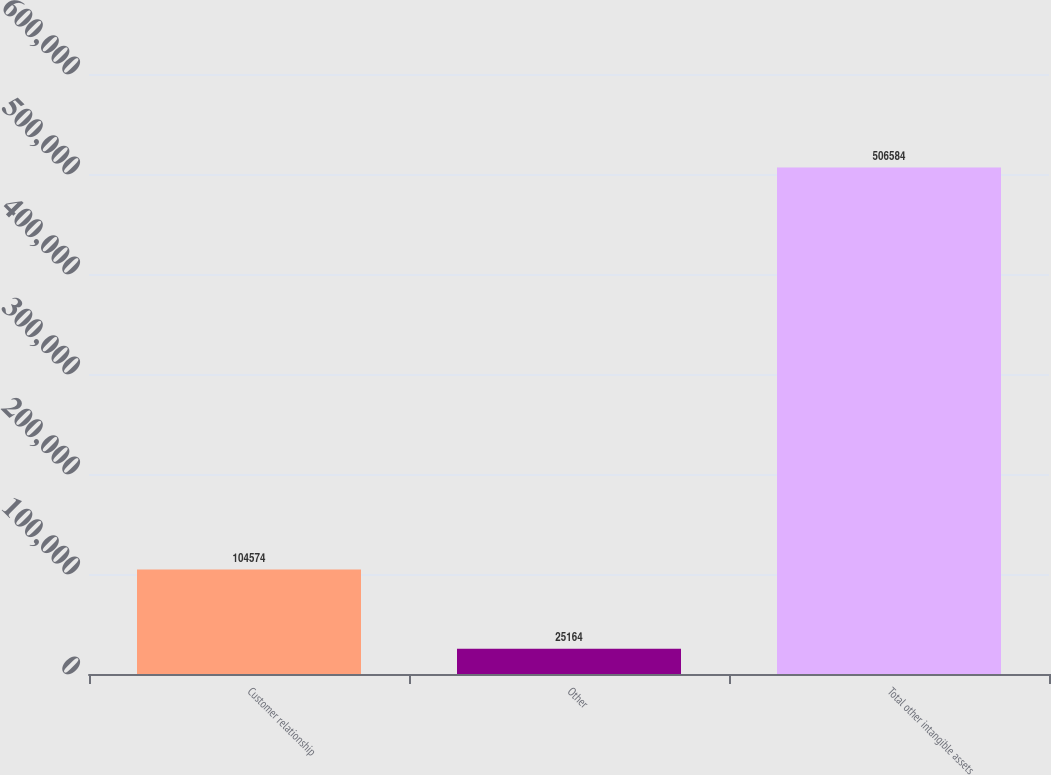<chart> <loc_0><loc_0><loc_500><loc_500><bar_chart><fcel>Customer relationship<fcel>Other<fcel>Total other intangible assets<nl><fcel>104574<fcel>25164<fcel>506584<nl></chart> 